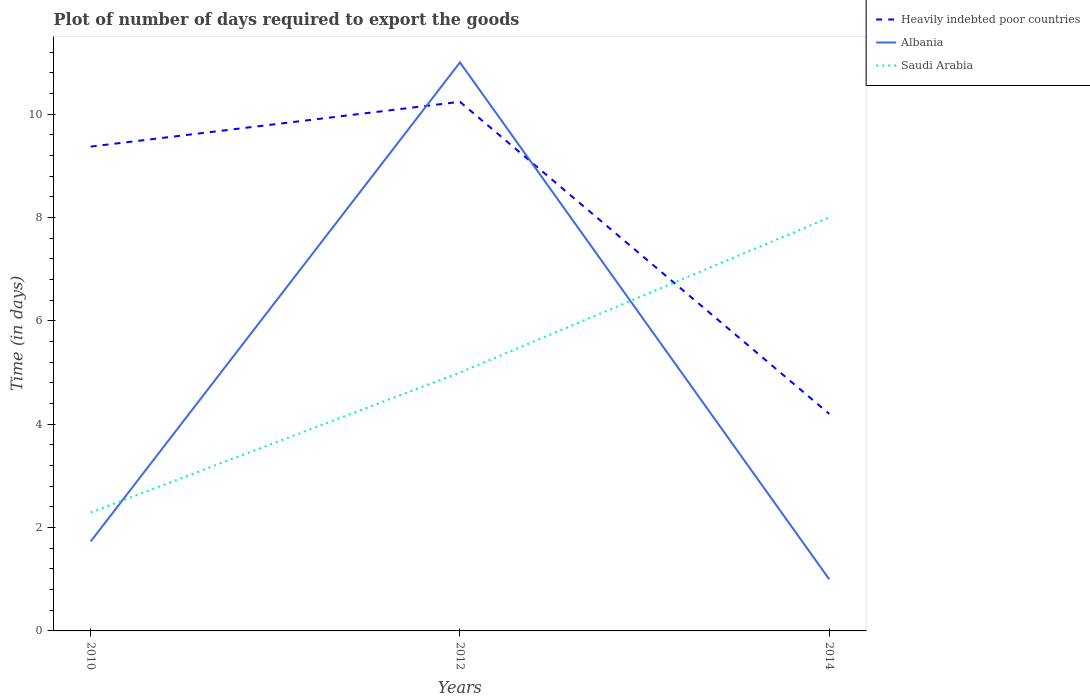Does the line corresponding to Saudi Arabia intersect with the line corresponding to Heavily indebted poor countries?
Provide a short and direct response. Yes. Is the number of lines equal to the number of legend labels?
Ensure brevity in your answer.  Yes. Across all years, what is the maximum time required to export goods in Heavily indebted poor countries?
Ensure brevity in your answer.  4.2. What is the difference between the highest and the second highest time required to export goods in Heavily indebted poor countries?
Your response must be concise. 6.04. What is the difference between the highest and the lowest time required to export goods in Saudi Arabia?
Your answer should be very brief. 1. Is the time required to export goods in Heavily indebted poor countries strictly greater than the time required to export goods in Saudi Arabia over the years?
Keep it short and to the point. No. Are the values on the major ticks of Y-axis written in scientific E-notation?
Your answer should be very brief. No. How many legend labels are there?
Ensure brevity in your answer.  3. How are the legend labels stacked?
Ensure brevity in your answer.  Vertical. What is the title of the graph?
Provide a succinct answer. Plot of number of days required to export the goods. What is the label or title of the X-axis?
Keep it short and to the point. Years. What is the label or title of the Y-axis?
Offer a very short reply. Time (in days). What is the Time (in days) in Heavily indebted poor countries in 2010?
Provide a short and direct response. 9.37. What is the Time (in days) in Albania in 2010?
Your answer should be very brief. 1.73. What is the Time (in days) of Saudi Arabia in 2010?
Offer a very short reply. 2.29. What is the Time (in days) in Heavily indebted poor countries in 2012?
Keep it short and to the point. 10.24. What is the Time (in days) in Albania in 2012?
Ensure brevity in your answer.  11. What is the Time (in days) of Saudi Arabia in 2012?
Provide a short and direct response. 5. What is the Time (in days) of Saudi Arabia in 2014?
Offer a terse response. 8. Across all years, what is the maximum Time (in days) of Heavily indebted poor countries?
Offer a very short reply. 10.24. Across all years, what is the maximum Time (in days) in Albania?
Ensure brevity in your answer.  11. Across all years, what is the maximum Time (in days) in Saudi Arabia?
Ensure brevity in your answer.  8. Across all years, what is the minimum Time (in days) in Heavily indebted poor countries?
Your answer should be compact. 4.2. Across all years, what is the minimum Time (in days) in Saudi Arabia?
Your response must be concise. 2.29. What is the total Time (in days) in Heavily indebted poor countries in the graph?
Ensure brevity in your answer.  23.81. What is the total Time (in days) of Albania in the graph?
Provide a succinct answer. 13.73. What is the total Time (in days) in Saudi Arabia in the graph?
Give a very brief answer. 15.29. What is the difference between the Time (in days) in Heavily indebted poor countries in 2010 and that in 2012?
Provide a succinct answer. -0.87. What is the difference between the Time (in days) in Albania in 2010 and that in 2012?
Provide a short and direct response. -9.27. What is the difference between the Time (in days) in Saudi Arabia in 2010 and that in 2012?
Offer a terse response. -2.71. What is the difference between the Time (in days) of Heavily indebted poor countries in 2010 and that in 2014?
Your answer should be very brief. 5.17. What is the difference between the Time (in days) of Albania in 2010 and that in 2014?
Make the answer very short. 0.73. What is the difference between the Time (in days) of Saudi Arabia in 2010 and that in 2014?
Provide a short and direct response. -5.71. What is the difference between the Time (in days) in Heavily indebted poor countries in 2012 and that in 2014?
Offer a very short reply. 6.04. What is the difference between the Time (in days) in Albania in 2012 and that in 2014?
Your answer should be compact. 10. What is the difference between the Time (in days) in Heavily indebted poor countries in 2010 and the Time (in days) in Albania in 2012?
Offer a very short reply. -1.63. What is the difference between the Time (in days) in Heavily indebted poor countries in 2010 and the Time (in days) in Saudi Arabia in 2012?
Offer a terse response. 4.37. What is the difference between the Time (in days) in Albania in 2010 and the Time (in days) in Saudi Arabia in 2012?
Your answer should be compact. -3.27. What is the difference between the Time (in days) of Heavily indebted poor countries in 2010 and the Time (in days) of Albania in 2014?
Provide a short and direct response. 8.37. What is the difference between the Time (in days) in Heavily indebted poor countries in 2010 and the Time (in days) in Saudi Arabia in 2014?
Keep it short and to the point. 1.37. What is the difference between the Time (in days) in Albania in 2010 and the Time (in days) in Saudi Arabia in 2014?
Ensure brevity in your answer.  -6.27. What is the difference between the Time (in days) in Heavily indebted poor countries in 2012 and the Time (in days) in Albania in 2014?
Keep it short and to the point. 9.24. What is the difference between the Time (in days) of Heavily indebted poor countries in 2012 and the Time (in days) of Saudi Arabia in 2014?
Offer a very short reply. 2.24. What is the average Time (in days) of Heavily indebted poor countries per year?
Offer a terse response. 7.94. What is the average Time (in days) in Albania per year?
Ensure brevity in your answer.  4.58. What is the average Time (in days) of Saudi Arabia per year?
Your response must be concise. 5.1. In the year 2010, what is the difference between the Time (in days) in Heavily indebted poor countries and Time (in days) in Albania?
Your answer should be compact. 7.64. In the year 2010, what is the difference between the Time (in days) of Heavily indebted poor countries and Time (in days) of Saudi Arabia?
Provide a succinct answer. 7.08. In the year 2010, what is the difference between the Time (in days) of Albania and Time (in days) of Saudi Arabia?
Ensure brevity in your answer.  -0.56. In the year 2012, what is the difference between the Time (in days) of Heavily indebted poor countries and Time (in days) of Albania?
Make the answer very short. -0.76. In the year 2012, what is the difference between the Time (in days) in Heavily indebted poor countries and Time (in days) in Saudi Arabia?
Your answer should be compact. 5.24. In the year 2012, what is the difference between the Time (in days) in Albania and Time (in days) in Saudi Arabia?
Offer a terse response. 6. In the year 2014, what is the difference between the Time (in days) of Heavily indebted poor countries and Time (in days) of Saudi Arabia?
Offer a very short reply. -3.8. In the year 2014, what is the difference between the Time (in days) of Albania and Time (in days) of Saudi Arabia?
Provide a succinct answer. -7. What is the ratio of the Time (in days) in Heavily indebted poor countries in 2010 to that in 2012?
Give a very brief answer. 0.92. What is the ratio of the Time (in days) in Albania in 2010 to that in 2012?
Your answer should be very brief. 0.16. What is the ratio of the Time (in days) in Saudi Arabia in 2010 to that in 2012?
Make the answer very short. 0.46. What is the ratio of the Time (in days) in Heavily indebted poor countries in 2010 to that in 2014?
Make the answer very short. 2.23. What is the ratio of the Time (in days) of Albania in 2010 to that in 2014?
Your answer should be very brief. 1.73. What is the ratio of the Time (in days) of Saudi Arabia in 2010 to that in 2014?
Give a very brief answer. 0.29. What is the ratio of the Time (in days) of Heavily indebted poor countries in 2012 to that in 2014?
Make the answer very short. 2.44. What is the difference between the highest and the second highest Time (in days) of Heavily indebted poor countries?
Your answer should be compact. 0.87. What is the difference between the highest and the second highest Time (in days) of Albania?
Your response must be concise. 9.27. What is the difference between the highest and the lowest Time (in days) in Heavily indebted poor countries?
Your answer should be compact. 6.04. What is the difference between the highest and the lowest Time (in days) in Saudi Arabia?
Give a very brief answer. 5.71. 